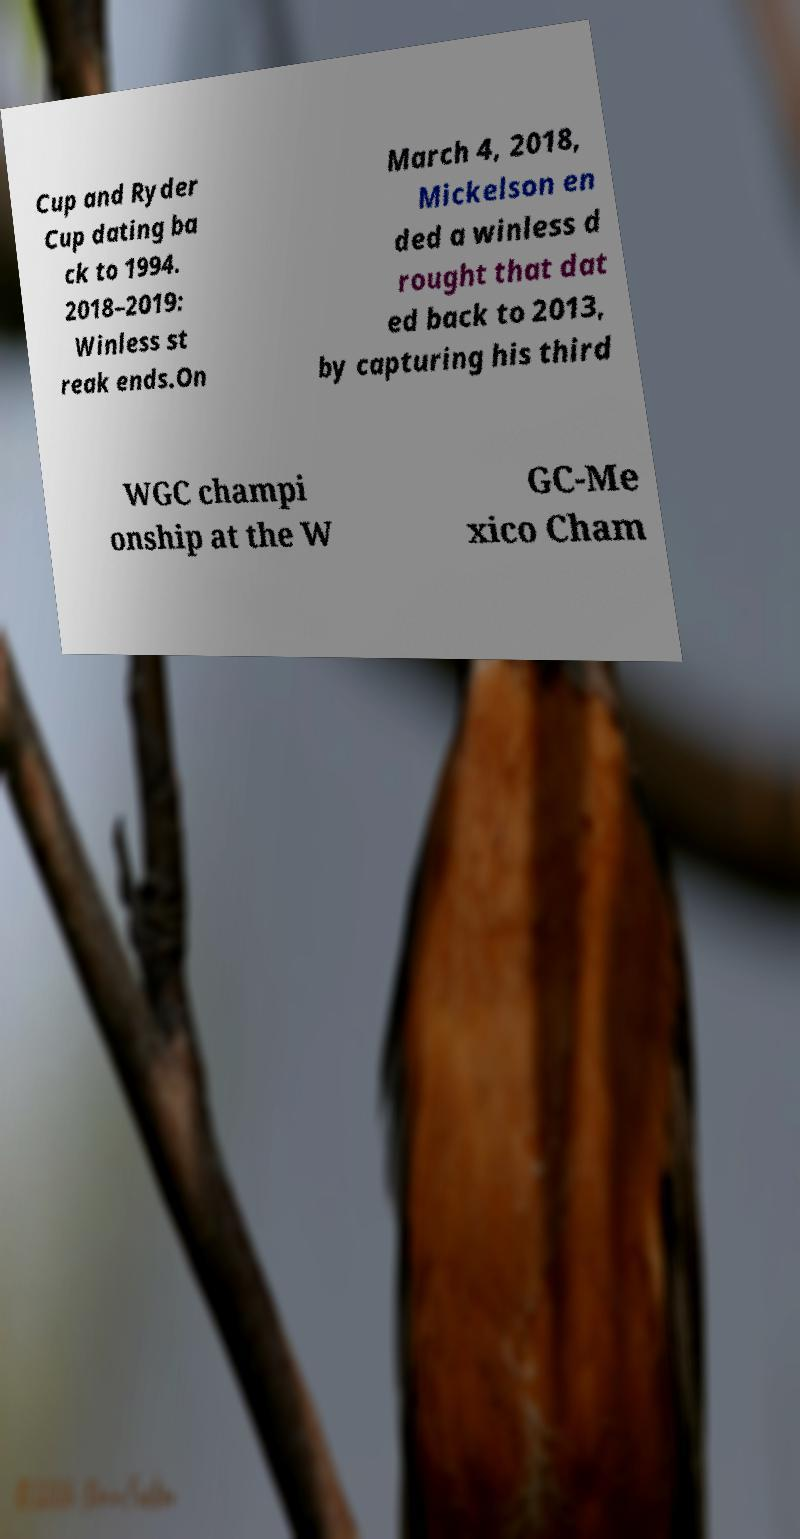What messages or text are displayed in this image? I need them in a readable, typed format. Cup and Ryder Cup dating ba ck to 1994. 2018–2019: Winless st reak ends.On March 4, 2018, Mickelson en ded a winless d rought that dat ed back to 2013, by capturing his third WGC champi onship at the W GC-Me xico Cham 